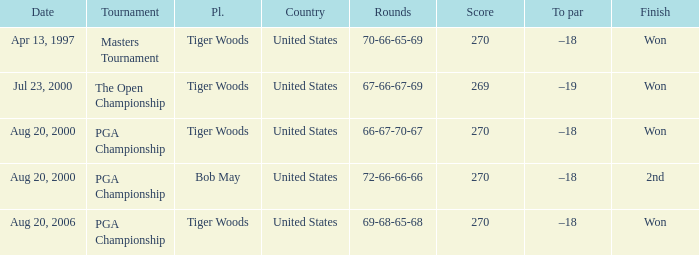What country hosts the tournament the open championship? United States. 